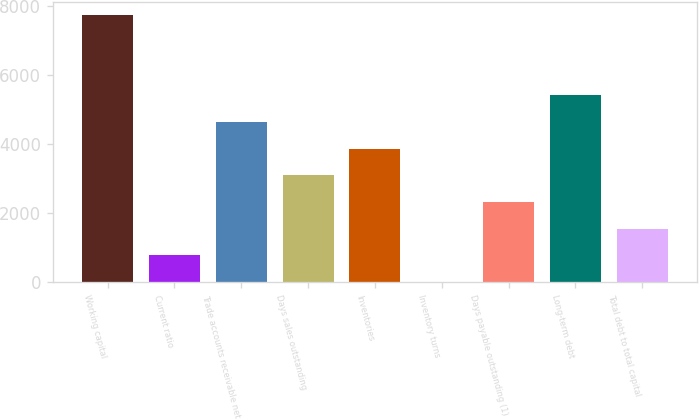Convert chart to OTSL. <chart><loc_0><loc_0><loc_500><loc_500><bar_chart><fcel>Working capital<fcel>Current ratio<fcel>Trade accounts receivable net<fcel>Days sales outstanding<fcel>Inventories<fcel>Inventory turns<fcel>Days payable outstanding (1)<fcel>Long-term debt<fcel>Total debt to total capital<nl><fcel>7739<fcel>778.13<fcel>4645.28<fcel>3098.42<fcel>3871.85<fcel>4.7<fcel>2324.99<fcel>5418.71<fcel>1551.56<nl></chart> 